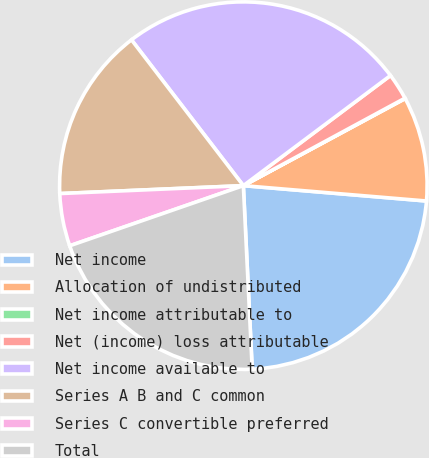<chart> <loc_0><loc_0><loc_500><loc_500><pie_chart><fcel>Net income<fcel>Allocation of undistributed<fcel>Net income attributable to<fcel>Net (income) loss attributable<fcel>Net income available to<fcel>Series A B and C common<fcel>Series C convertible preferred<fcel>Total<nl><fcel>22.9%<fcel>9.19%<fcel>0.04%<fcel>2.33%<fcel>25.19%<fcel>15.27%<fcel>4.62%<fcel>20.46%<nl></chart> 